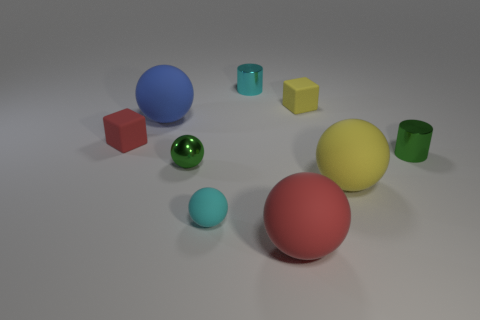Subtract all spheres. How many objects are left? 4 Add 8 yellow matte objects. How many yellow matte objects exist? 10 Subtract 0 brown cubes. How many objects are left? 9 Subtract all large purple cubes. Subtract all green metal balls. How many objects are left? 8 Add 5 cyan metal cylinders. How many cyan metal cylinders are left? 6 